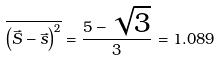Convert formula to latex. <formula><loc_0><loc_0><loc_500><loc_500>\overline { \left ( \vec { S } - \vec { s } \right ) ^ { 2 } } = \frac { 5 - \sqrt { 3 } } { 3 } = 1 . 0 8 9</formula> 